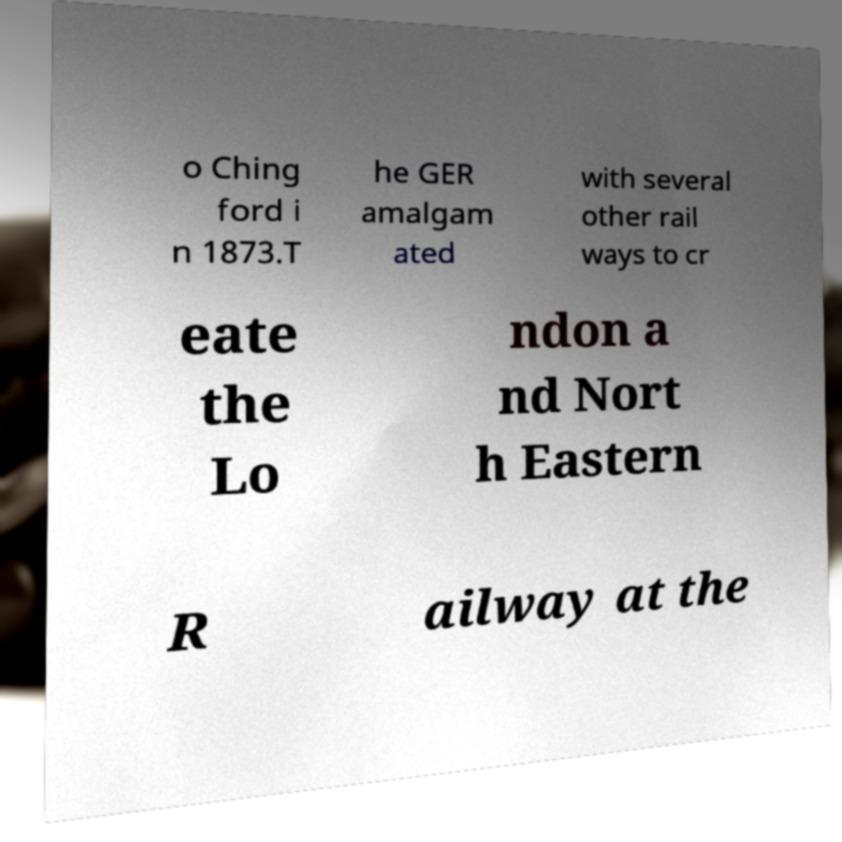Can you accurately transcribe the text from the provided image for me? o Ching ford i n 1873.T he GER amalgam ated with several other rail ways to cr eate the Lo ndon a nd Nort h Eastern R ailway at the 